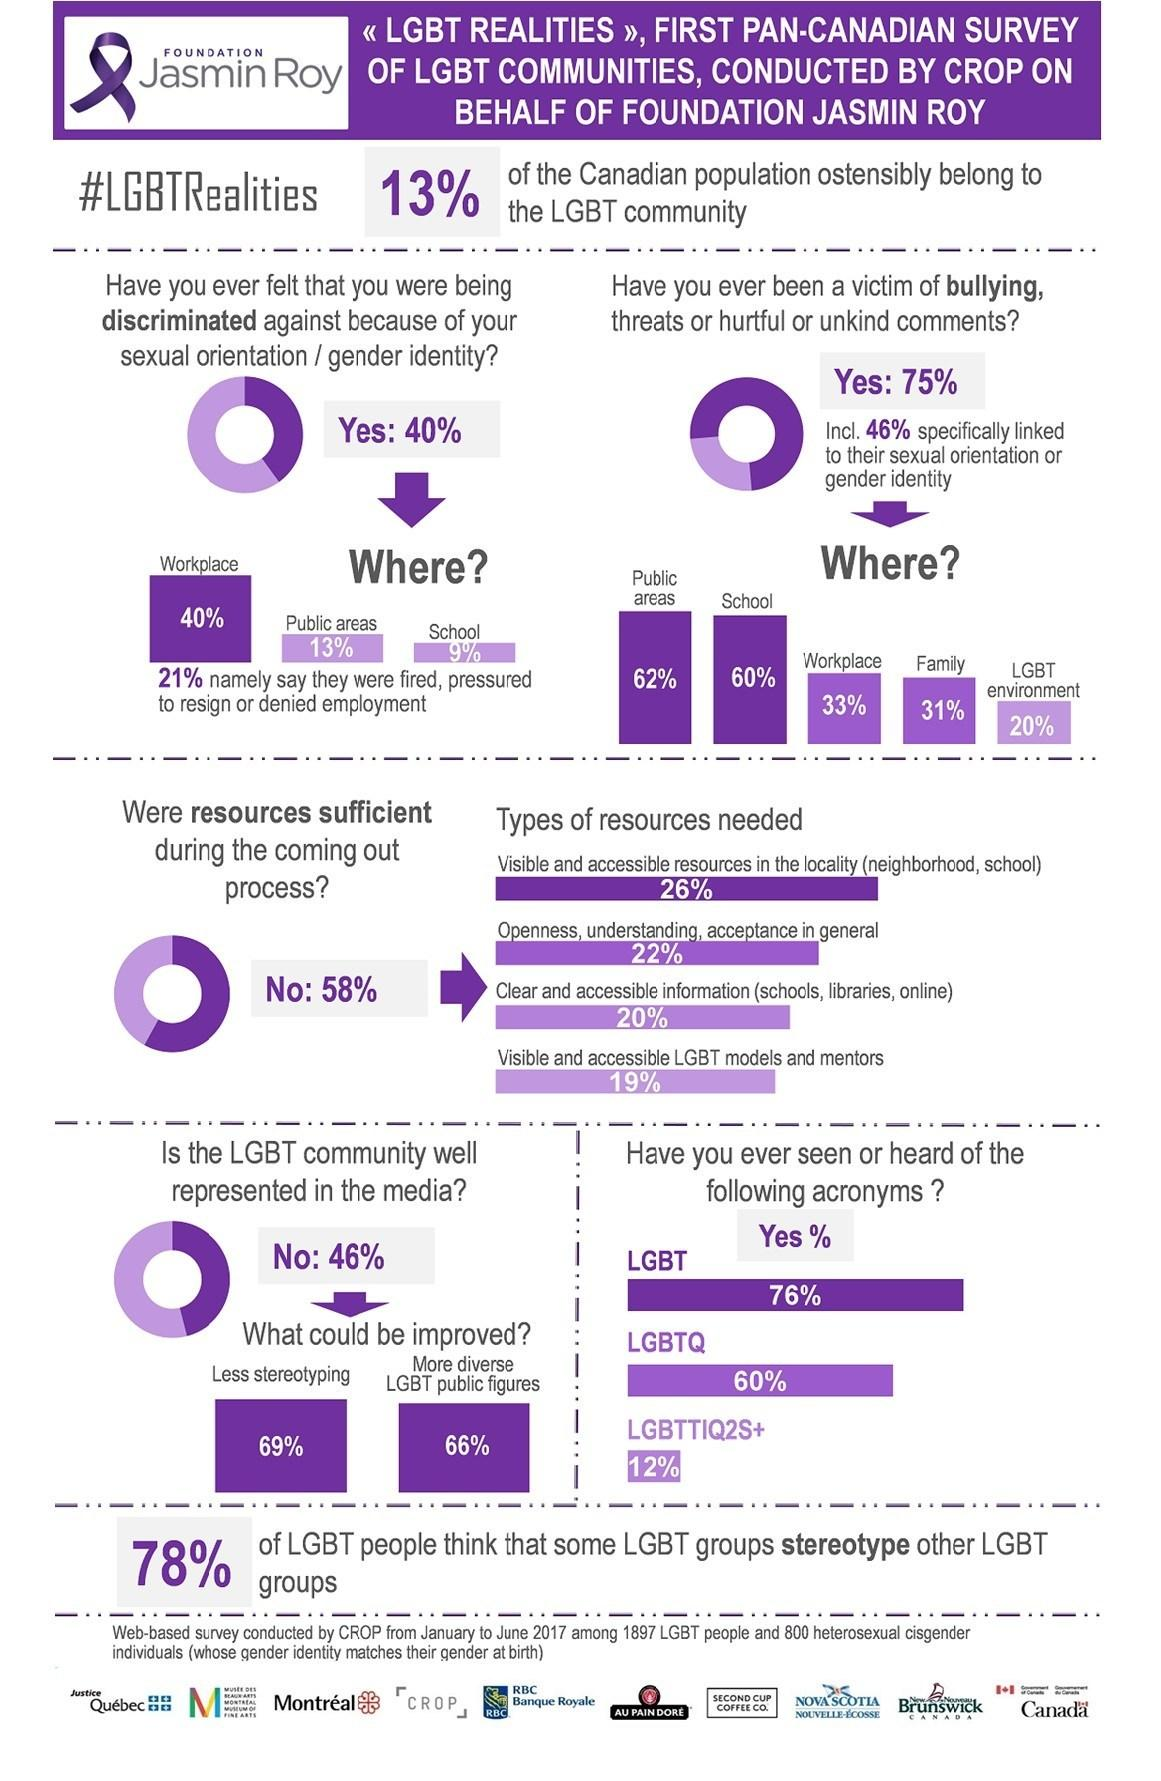Point out several critical features in this image. According to the survey, 46% of respondents believe that the LGBT community is not well represented in media. Discrimination has occurred in 13% of public areas. Sixty percent of the bullying occurred at school. There should be a significant improvement in the representation of LGBT public figures in order to promote diversity and inclusion in society. The discrimination was felt by 40% of people in the workplace. 